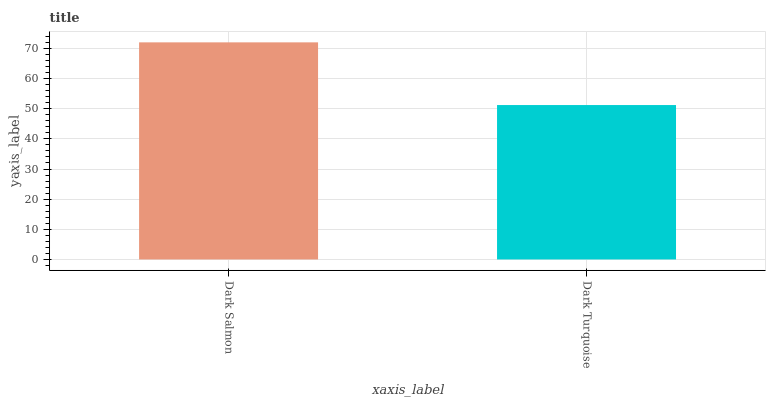Is Dark Turquoise the minimum?
Answer yes or no. Yes. Is Dark Salmon the maximum?
Answer yes or no. Yes. Is Dark Turquoise the maximum?
Answer yes or no. No. Is Dark Salmon greater than Dark Turquoise?
Answer yes or no. Yes. Is Dark Turquoise less than Dark Salmon?
Answer yes or no. Yes. Is Dark Turquoise greater than Dark Salmon?
Answer yes or no. No. Is Dark Salmon less than Dark Turquoise?
Answer yes or no. No. Is Dark Salmon the high median?
Answer yes or no. Yes. Is Dark Turquoise the low median?
Answer yes or no. Yes. Is Dark Turquoise the high median?
Answer yes or no. No. Is Dark Salmon the low median?
Answer yes or no. No. 